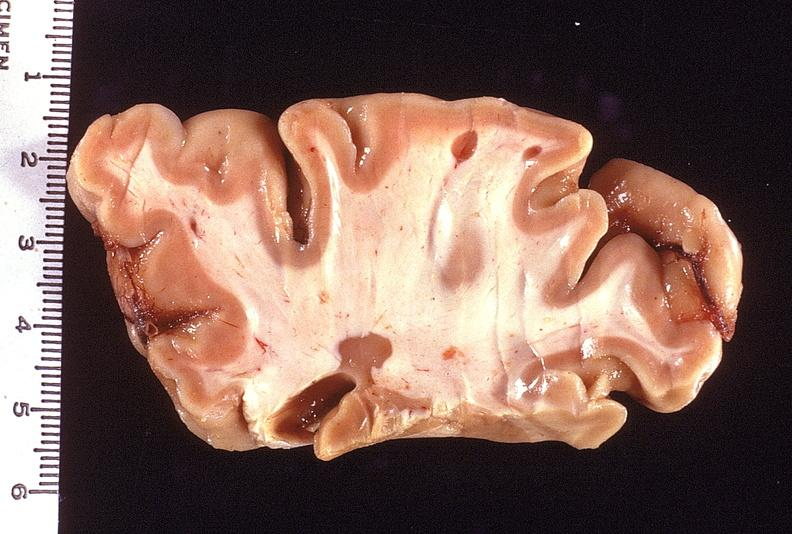what is present?
Answer the question using a single word or phrase. Nervous 